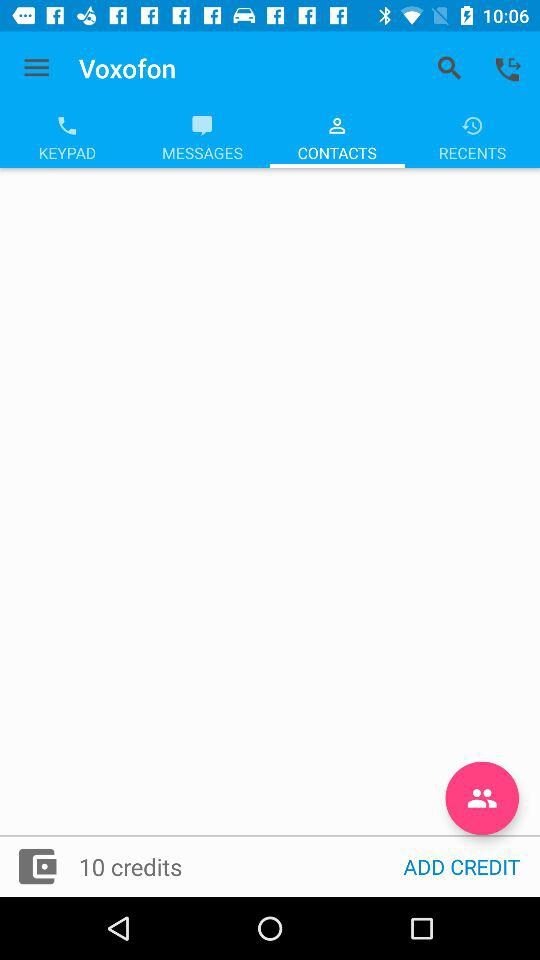How many credits do I have?
Answer the question using a single word or phrase. 10 